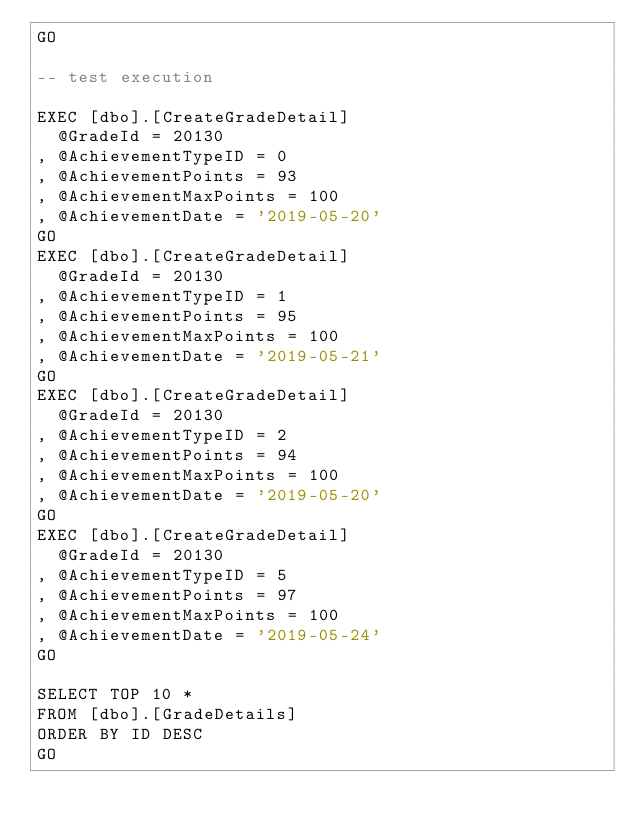Convert code to text. <code><loc_0><loc_0><loc_500><loc_500><_SQL_>GO
	
-- test execution

EXEC [dbo].[CreateGradeDetail]
	@GradeId = 20130
,	@AchievementTypeID = 0
,	@AchievementPoints = 93
,	@AchievementMaxPoints = 100
,	@AchievementDate = '2019-05-20'
GO
EXEC [dbo].[CreateGradeDetail]
	@GradeId = 20130
,	@AchievementTypeID = 1
,	@AchievementPoints = 95
,	@AchievementMaxPoints = 100
,	@AchievementDate = '2019-05-21'
GO
EXEC [dbo].[CreateGradeDetail]
	@GradeId = 20130
,	@AchievementTypeID = 2
,	@AchievementPoints = 94
,	@AchievementMaxPoints = 100
,	@AchievementDate = '2019-05-20'
GO
EXEC [dbo].[CreateGradeDetail]
	@GradeId = 20130
,	@AchievementTypeID = 5
,	@AchievementPoints = 97
,	@AchievementMaxPoints = 100
,	@AchievementDate = '2019-05-24'
GO

SELECT TOP 10 * 
FROM [dbo].[GradeDetails]
ORDER BY ID DESC
GO
</code> 